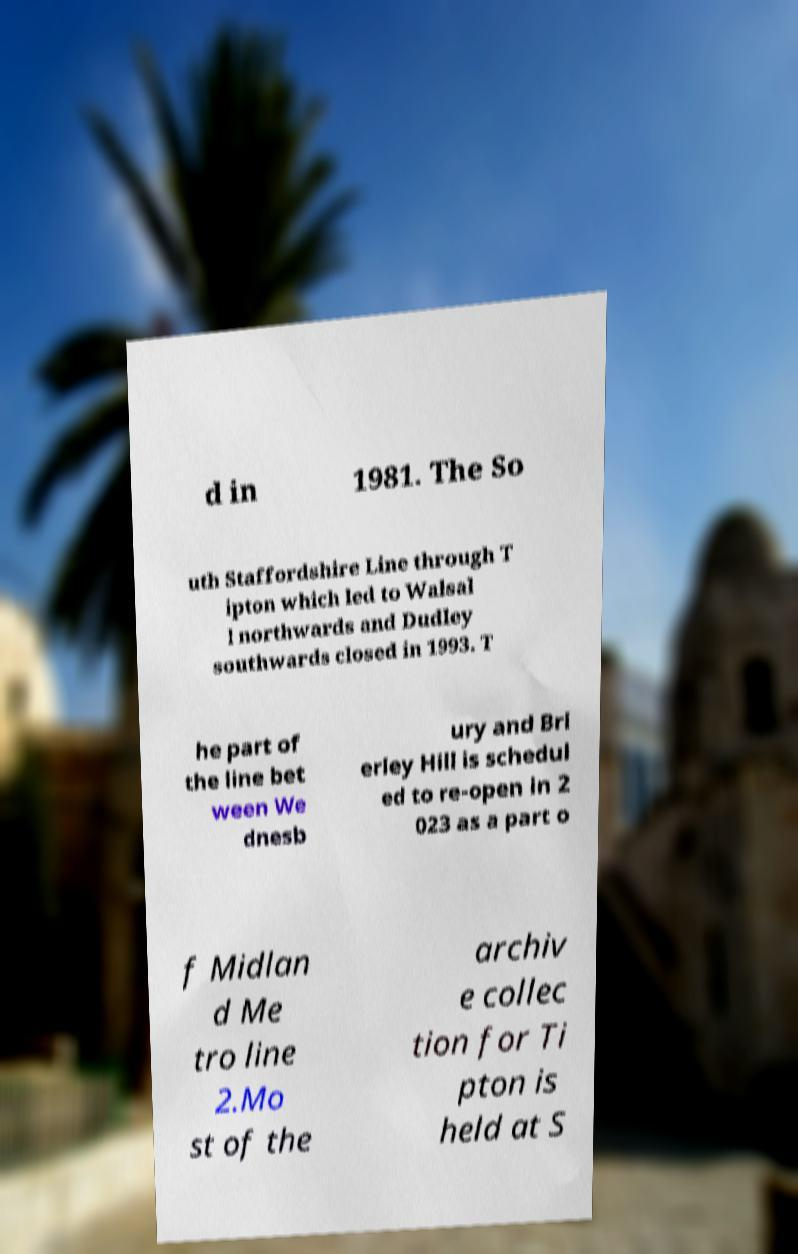For documentation purposes, I need the text within this image transcribed. Could you provide that? d in 1981. The So uth Staffordshire Line through T ipton which led to Walsal l northwards and Dudley southwards closed in 1993. T he part of the line bet ween We dnesb ury and Bri erley Hill is schedul ed to re-open in 2 023 as a part o f Midlan d Me tro line 2.Mo st of the archiv e collec tion for Ti pton is held at S 